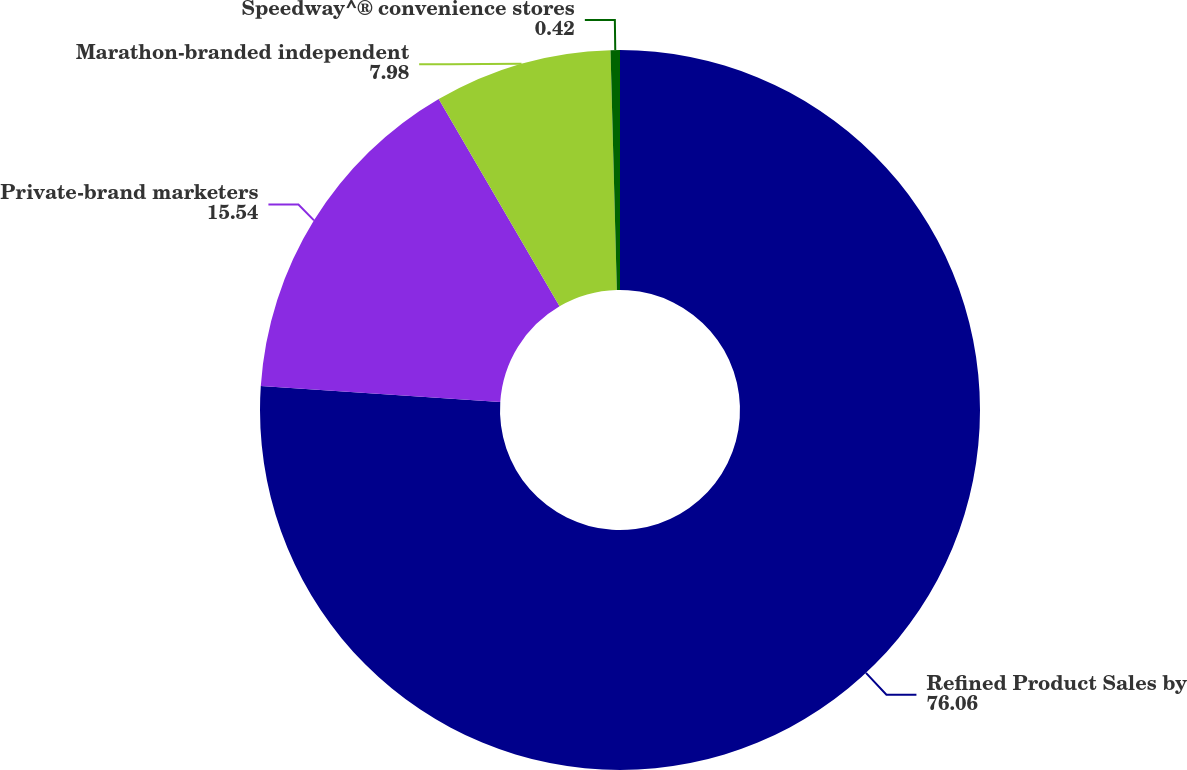Convert chart. <chart><loc_0><loc_0><loc_500><loc_500><pie_chart><fcel>Refined Product Sales by<fcel>Private-brand marketers<fcel>Marathon-branded independent<fcel>Speedway^® convenience stores<nl><fcel>76.06%<fcel>15.54%<fcel>7.98%<fcel>0.42%<nl></chart> 